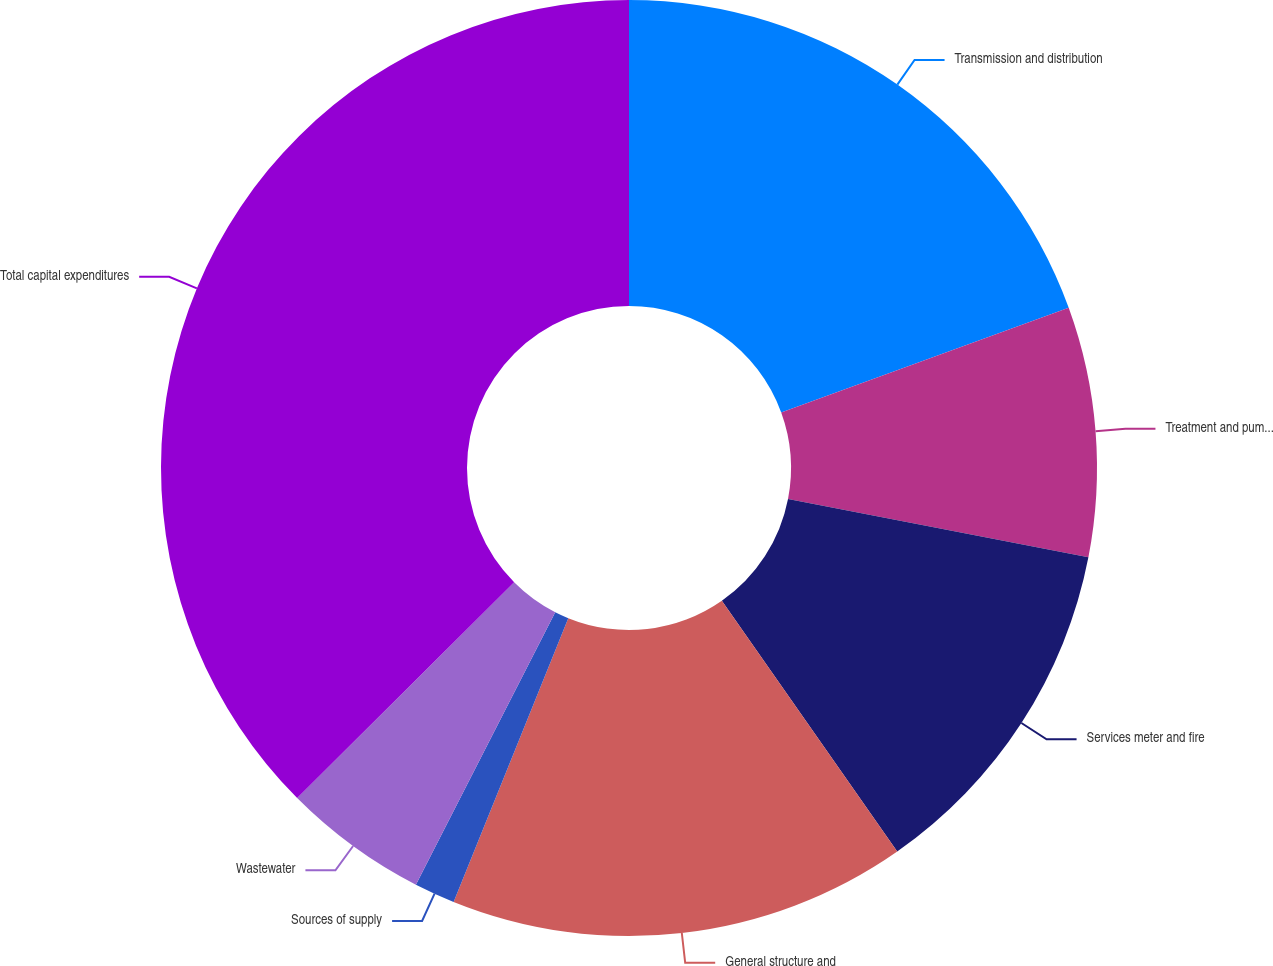<chart> <loc_0><loc_0><loc_500><loc_500><pie_chart><fcel>Transmission and distribution<fcel>Treatment and pumping<fcel>Services meter and fire<fcel>General structure and<fcel>Sources of supply<fcel>Wastewater<fcel>Total capital expenditures<nl><fcel>19.44%<fcel>8.62%<fcel>12.23%<fcel>15.83%<fcel>1.41%<fcel>5.02%<fcel>37.46%<nl></chart> 